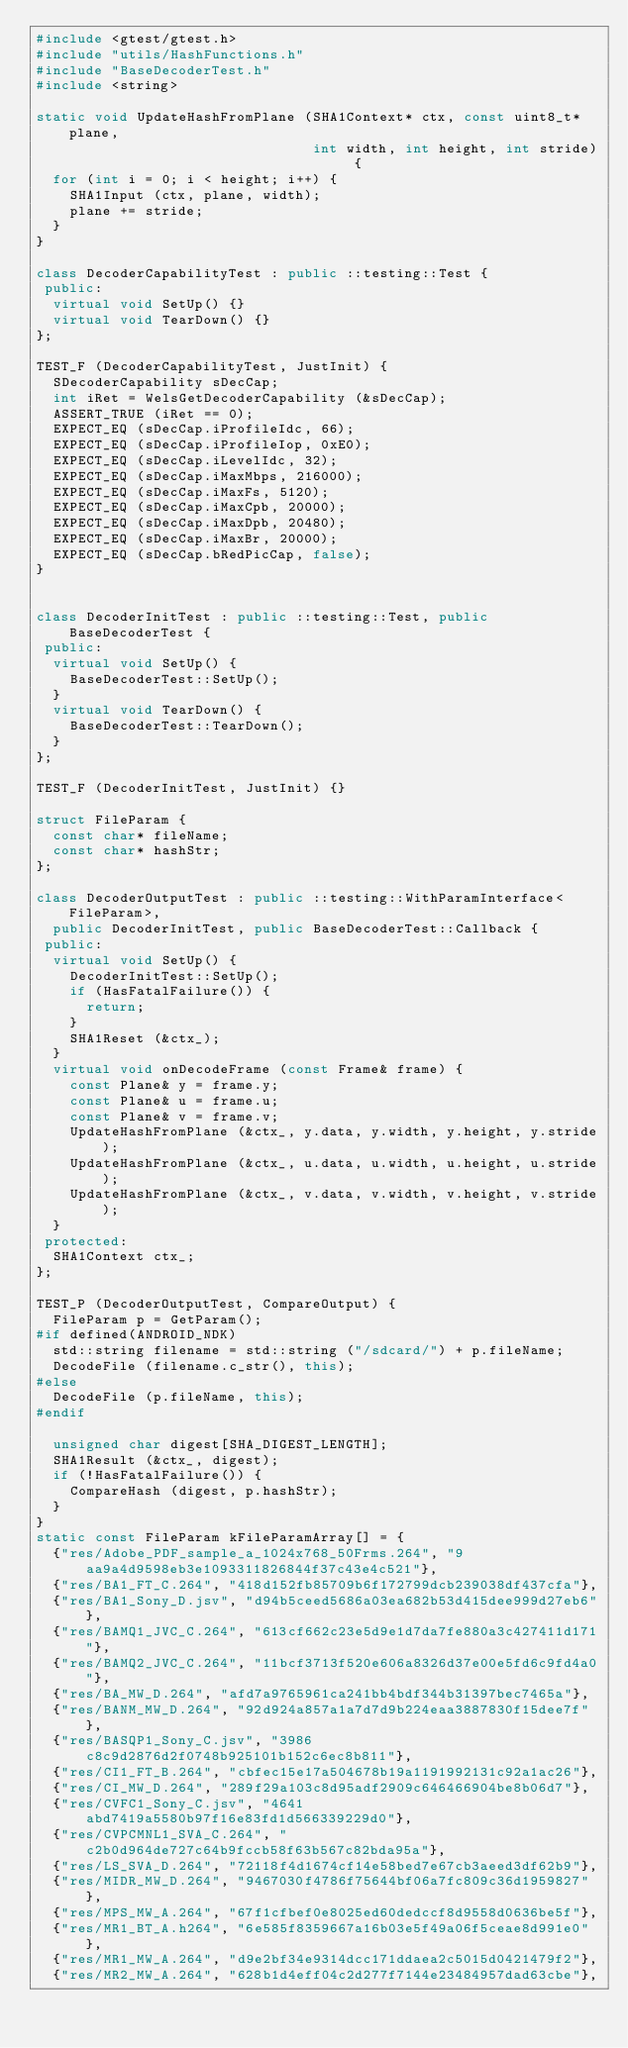<code> <loc_0><loc_0><loc_500><loc_500><_C++_>#include <gtest/gtest.h>
#include "utils/HashFunctions.h"
#include "BaseDecoderTest.h"
#include <string>

static void UpdateHashFromPlane (SHA1Context* ctx, const uint8_t* plane,
                                 int width, int height, int stride) {
  for (int i = 0; i < height; i++) {
    SHA1Input (ctx, plane, width);
    plane += stride;
  }
}

class DecoderCapabilityTest : public ::testing::Test {
 public:
  virtual void SetUp() {}
  virtual void TearDown() {}
};

TEST_F (DecoderCapabilityTest, JustInit) {
  SDecoderCapability sDecCap;
  int iRet = WelsGetDecoderCapability (&sDecCap);
  ASSERT_TRUE (iRet == 0);
  EXPECT_EQ (sDecCap.iProfileIdc, 66);
  EXPECT_EQ (sDecCap.iProfileIop, 0xE0);
  EXPECT_EQ (sDecCap.iLevelIdc, 32);
  EXPECT_EQ (sDecCap.iMaxMbps, 216000);
  EXPECT_EQ (sDecCap.iMaxFs, 5120);
  EXPECT_EQ (sDecCap.iMaxCpb, 20000);
  EXPECT_EQ (sDecCap.iMaxDpb, 20480);
  EXPECT_EQ (sDecCap.iMaxBr, 20000);
  EXPECT_EQ (sDecCap.bRedPicCap, false);
}


class DecoderInitTest : public ::testing::Test, public BaseDecoderTest {
 public:
  virtual void SetUp() {
    BaseDecoderTest::SetUp();
  }
  virtual void TearDown() {
    BaseDecoderTest::TearDown();
  }
};

TEST_F (DecoderInitTest, JustInit) {}

struct FileParam {
  const char* fileName;
  const char* hashStr;
};

class DecoderOutputTest : public ::testing::WithParamInterface<FileParam>,
  public DecoderInitTest, public BaseDecoderTest::Callback {
 public:
  virtual void SetUp() {
    DecoderInitTest::SetUp();
    if (HasFatalFailure()) {
      return;
    }
    SHA1Reset (&ctx_);
  }
  virtual void onDecodeFrame (const Frame& frame) {
    const Plane& y = frame.y;
    const Plane& u = frame.u;
    const Plane& v = frame.v;
    UpdateHashFromPlane (&ctx_, y.data, y.width, y.height, y.stride);
    UpdateHashFromPlane (&ctx_, u.data, u.width, u.height, u.stride);
    UpdateHashFromPlane (&ctx_, v.data, v.width, v.height, v.stride);
  }
 protected:
  SHA1Context ctx_;
};

TEST_P (DecoderOutputTest, CompareOutput) {
  FileParam p = GetParam();
#if defined(ANDROID_NDK)
  std::string filename = std::string ("/sdcard/") + p.fileName;
  DecodeFile (filename.c_str(), this);
#else
  DecodeFile (p.fileName, this);
#endif

  unsigned char digest[SHA_DIGEST_LENGTH];
  SHA1Result (&ctx_, digest);
  if (!HasFatalFailure()) {
    CompareHash (digest, p.hashStr);
  }
}
static const FileParam kFileParamArray[] = {
  {"res/Adobe_PDF_sample_a_1024x768_50Frms.264", "9aa9a4d9598eb3e1093311826844f37c43e4c521"},
  {"res/BA1_FT_C.264", "418d152fb85709b6f172799dcb239038df437cfa"},
  {"res/BA1_Sony_D.jsv", "d94b5ceed5686a03ea682b53d415dee999d27eb6"},
  {"res/BAMQ1_JVC_C.264", "613cf662c23e5d9e1d7da7fe880a3c427411d171"},
  {"res/BAMQ2_JVC_C.264", "11bcf3713f520e606a8326d37e00e5fd6c9fd4a0"},
  {"res/BA_MW_D.264", "afd7a9765961ca241bb4bdf344b31397bec7465a"},
  {"res/BANM_MW_D.264", "92d924a857a1a7d7d9b224eaa3887830f15dee7f"},
  {"res/BASQP1_Sony_C.jsv", "3986c8c9d2876d2f0748b925101b152c6ec8b811"},
  {"res/CI1_FT_B.264", "cbfec15e17a504678b19a1191992131c92a1ac26"},
  {"res/CI_MW_D.264", "289f29a103c8d95adf2909c646466904be8b06d7"},
  {"res/CVFC1_Sony_C.jsv", "4641abd7419a5580b97f16e83fd1d566339229d0"},
  {"res/CVPCMNL1_SVA_C.264", "c2b0d964de727c64b9fccb58f63b567c82bda95a"},
  {"res/LS_SVA_D.264", "72118f4d1674cf14e58bed7e67cb3aeed3df62b9"},
  {"res/MIDR_MW_D.264", "9467030f4786f75644bf06a7fc809c36d1959827"},
  {"res/MPS_MW_A.264", "67f1cfbef0e8025ed60dedccf8d9558d0636be5f"},
  {"res/MR1_BT_A.h264", "6e585f8359667a16b03e5f49a06f5ceae8d991e0"},
  {"res/MR1_MW_A.264", "d9e2bf34e9314dcc171ddaea2c5015d0421479f2"},
  {"res/MR2_MW_A.264", "628b1d4eff04c2d277f7144e23484957dad63cbe"},</code> 